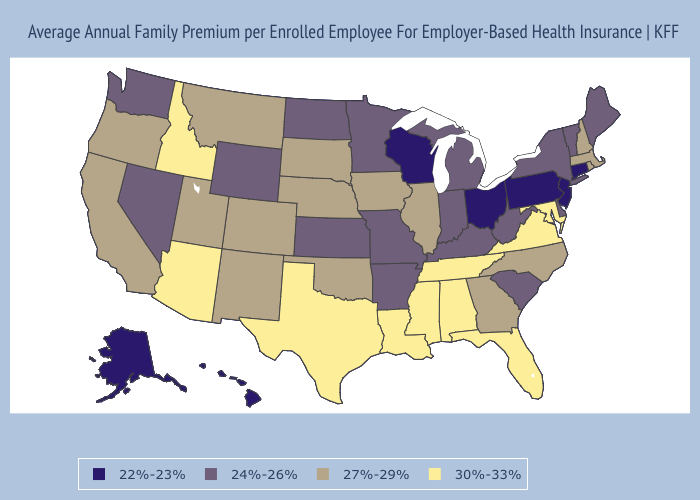What is the highest value in the MidWest ?
Short answer required. 27%-29%. Does Connecticut have a higher value than Oregon?
Quick response, please. No. Among the states that border Nebraska , which have the lowest value?
Be succinct. Kansas, Missouri, Wyoming. What is the value of Alabama?
Be succinct. 30%-33%. Does Illinois have the lowest value in the MidWest?
Give a very brief answer. No. What is the lowest value in the MidWest?
Write a very short answer. 22%-23%. Among the states that border Delaware , which have the highest value?
Keep it brief. Maryland. Among the states that border Connecticut , does New York have the highest value?
Be succinct. No. Among the states that border West Virginia , does Ohio have the lowest value?
Concise answer only. Yes. Among the states that border North Carolina , does Virginia have the lowest value?
Give a very brief answer. No. What is the value of Idaho?
Be succinct. 30%-33%. What is the highest value in the USA?
Give a very brief answer. 30%-33%. Name the states that have a value in the range 30%-33%?
Give a very brief answer. Alabama, Arizona, Florida, Idaho, Louisiana, Maryland, Mississippi, Tennessee, Texas, Virginia. Name the states that have a value in the range 22%-23%?
Be succinct. Alaska, Connecticut, Hawaii, New Jersey, Ohio, Pennsylvania, Wisconsin. Does the map have missing data?
Concise answer only. No. 